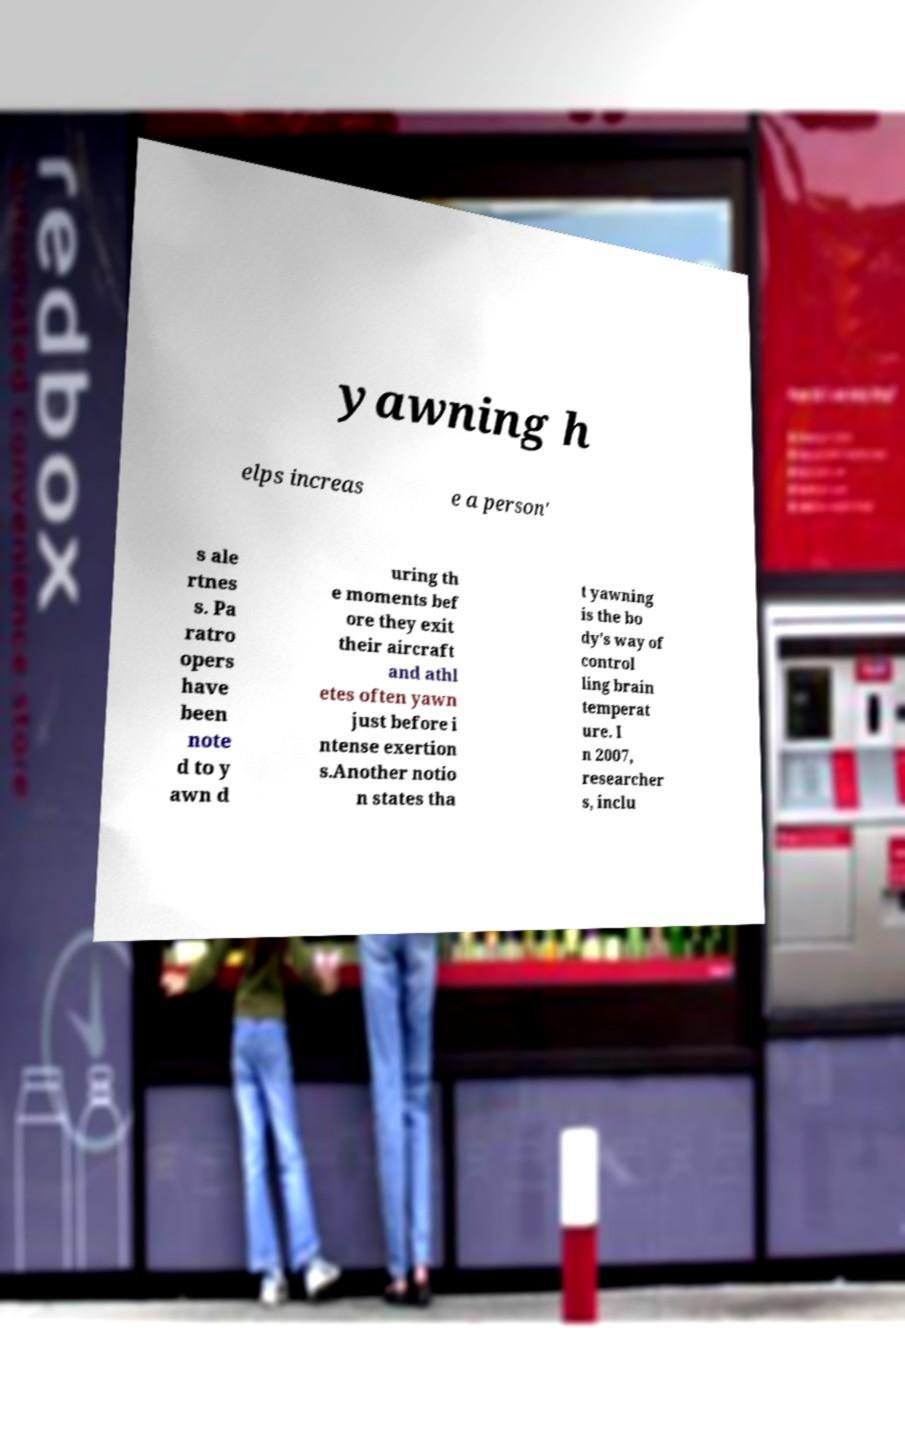Could you extract and type out the text from this image? yawning h elps increas e a person' s ale rtnes s. Pa ratro opers have been note d to y awn d uring th e moments bef ore they exit their aircraft and athl etes often yawn just before i ntense exertion s.Another notio n states tha t yawning is the bo dy's way of control ling brain temperat ure. I n 2007, researcher s, inclu 